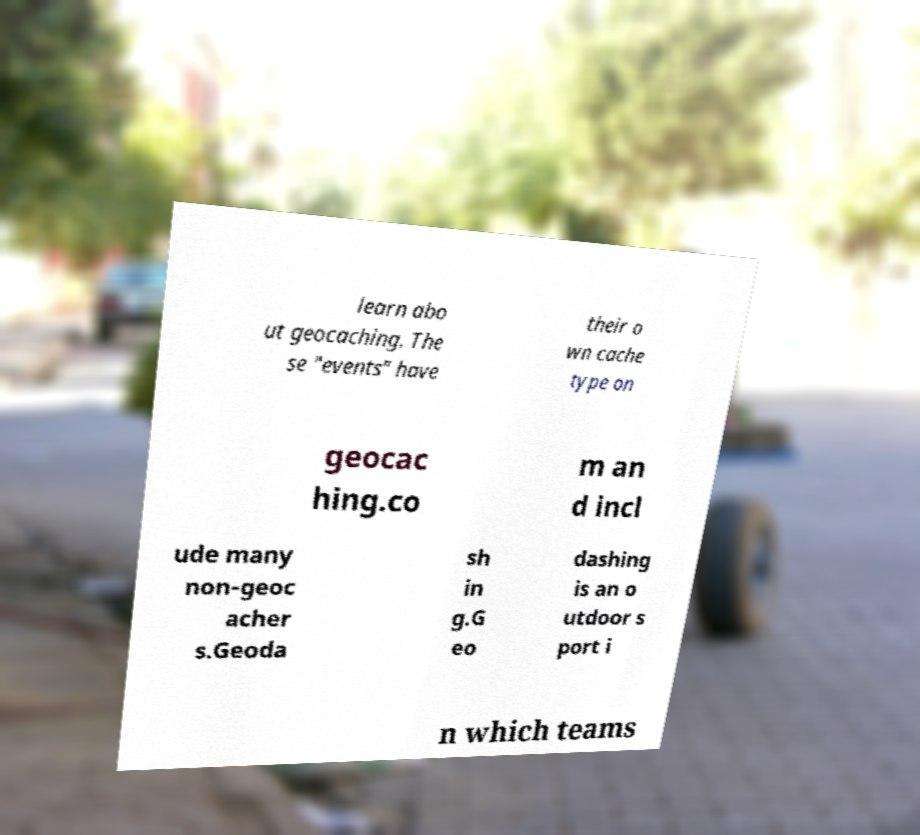Could you assist in decoding the text presented in this image and type it out clearly? learn abo ut geocaching. The se "events" have their o wn cache type on geocac hing.co m an d incl ude many non-geoc acher s.Geoda sh in g.G eo dashing is an o utdoor s port i n which teams 